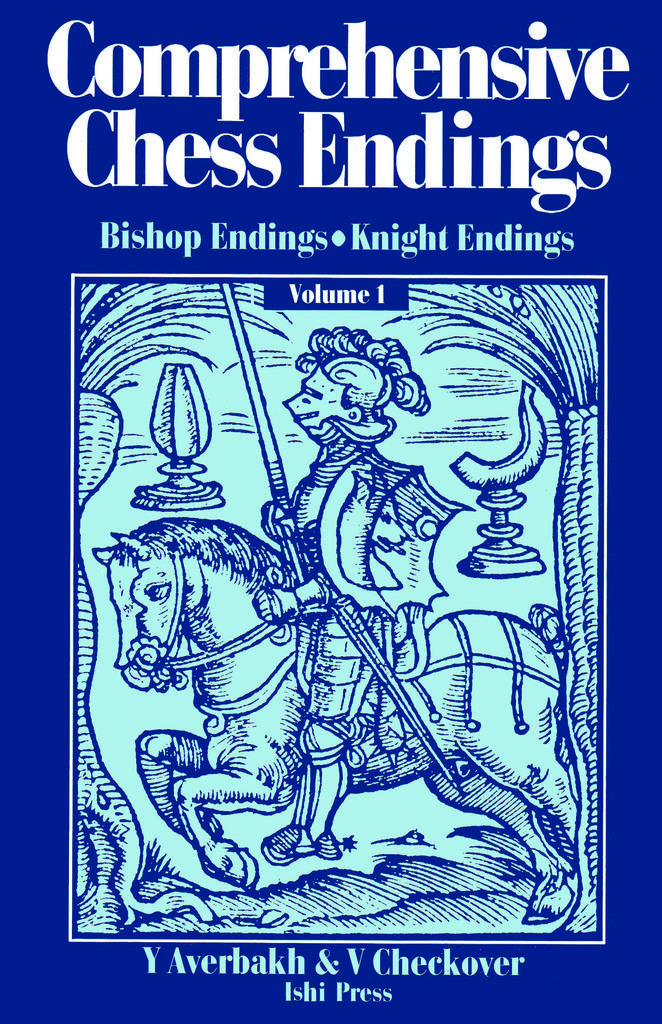What type of page is shown in the image? The image is a cover page of a book. What can be seen on the cover page? There is a picture on the cover page. Is there any text on the cover page? Yes, there is some text on the cover page. What color is the thread used to sew the magic spell on the cover page? There is no thread or magic spell present on the cover page; it only features a picture and text. 